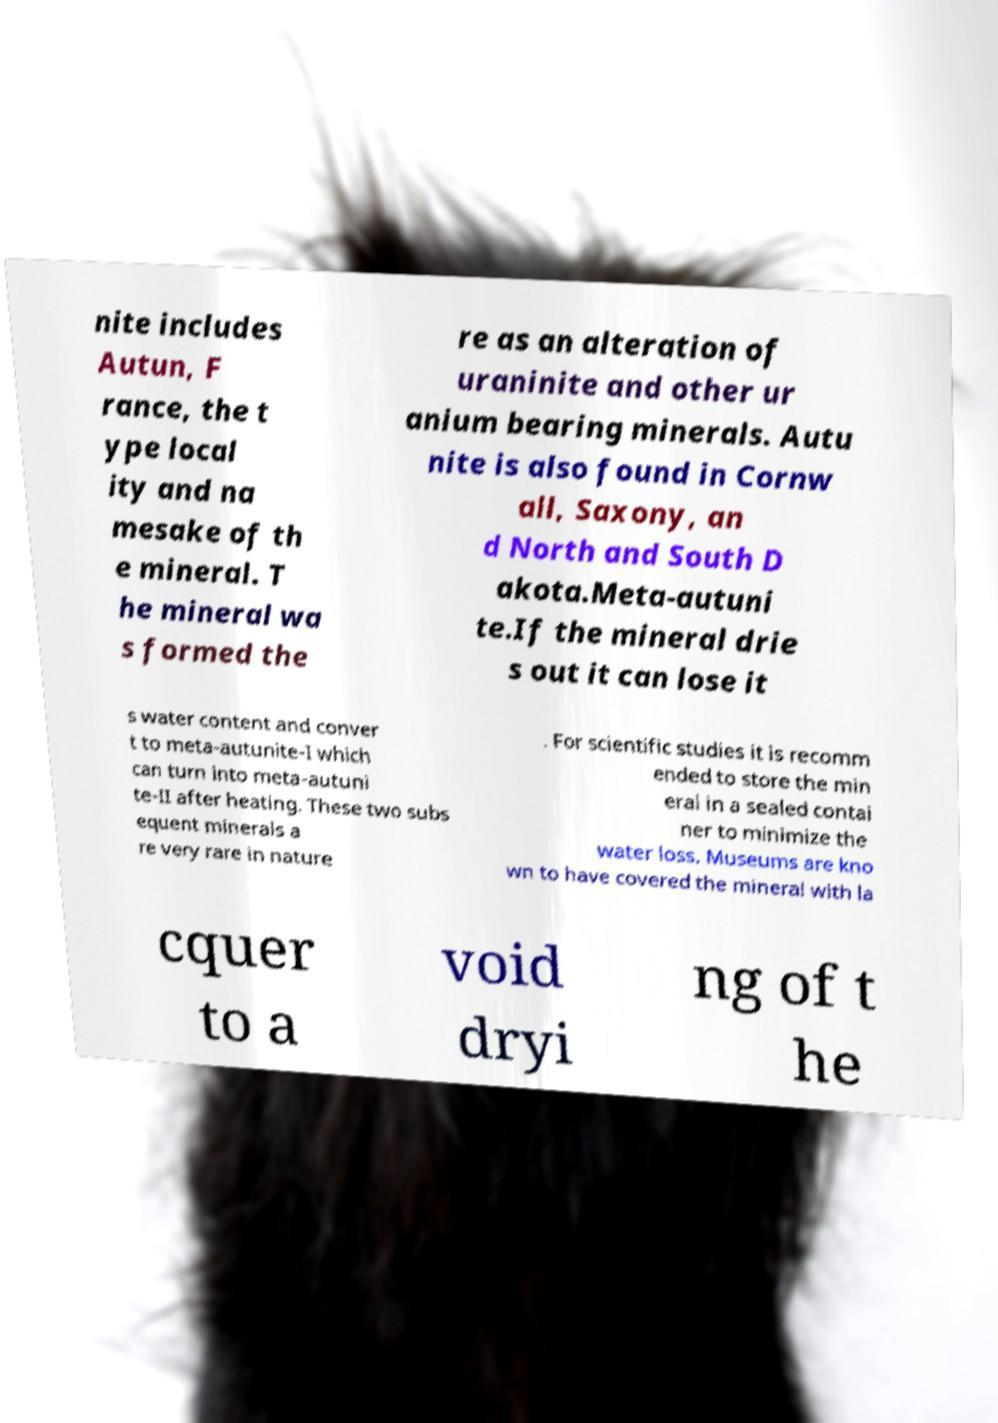There's text embedded in this image that I need extracted. Can you transcribe it verbatim? nite includes Autun, F rance, the t ype local ity and na mesake of th e mineral. T he mineral wa s formed the re as an alteration of uraninite and other ur anium bearing minerals. Autu nite is also found in Cornw all, Saxony, an d North and South D akota.Meta-autuni te.If the mineral drie s out it can lose it s water content and conver t to meta-autunite-I which can turn into meta-autuni te-II after heating. These two subs equent minerals a re very rare in nature . For scientific studies it is recomm ended to store the min eral in a sealed contai ner to minimize the water loss. Museums are kno wn to have covered the mineral with la cquer to a void dryi ng of t he 